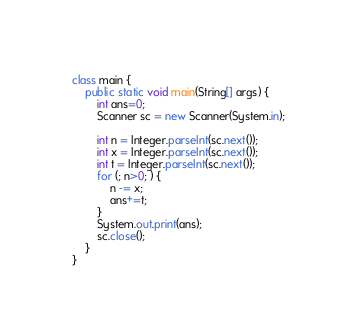Convert code to text. <code><loc_0><loc_0><loc_500><loc_500><_Java_>class main {
	public static void main(String[] args) {
		int ans=0;
		Scanner sc = new Scanner(System.in);
      
		int n = Integer.parseInt(sc.next());
		int x = Integer.parseInt(sc.next());
		int t = Integer.parseInt(sc.next());
		for (; n>0; ) {
			n -= x;
			ans+=t;
		}
		System.out.print(ans);
		sc.close();
	}
}</code> 